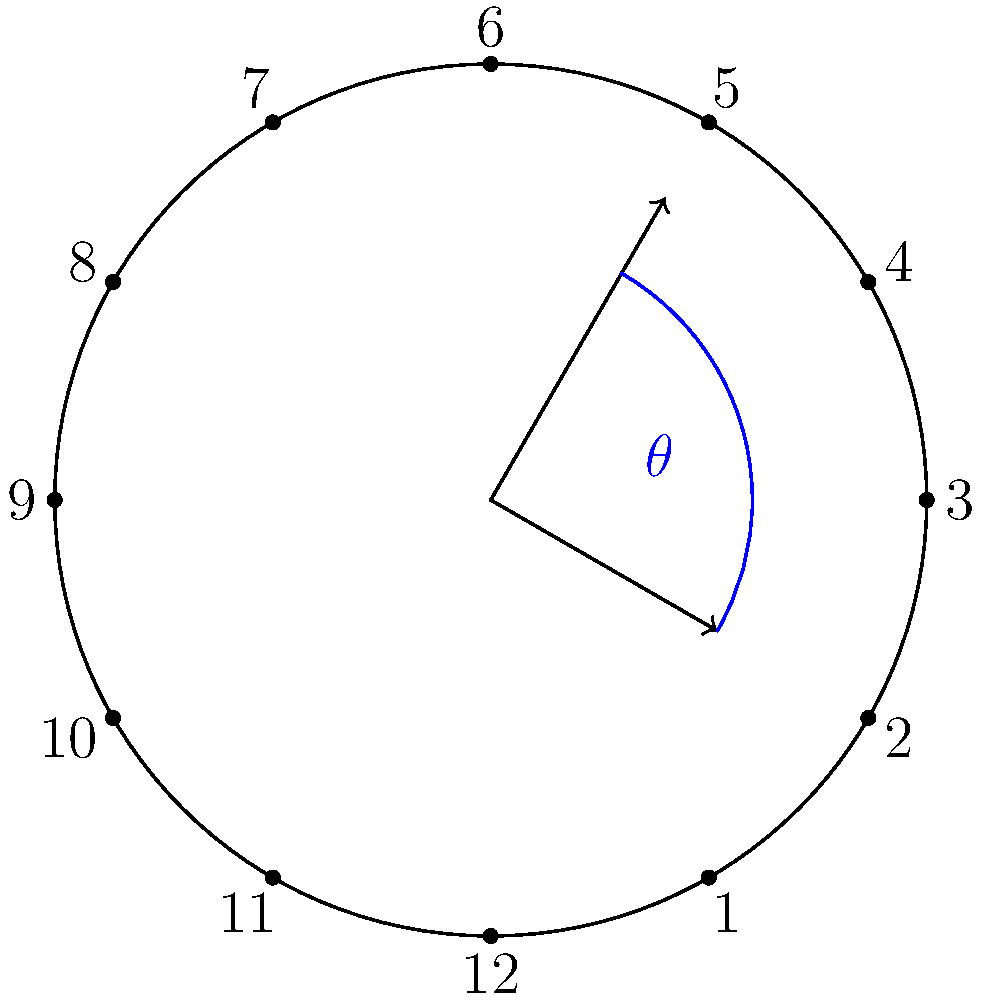Your child is learning to tell time on an analog clock. At 2:20, what is the angle between the hour hand and the minute hand? (Hint: Consider the movement of both hands.) Let's approach this step-by-step:

1. On a clock, there are 360° in a full rotation.

2. For the hour hand:
   - In 12 hours, it rotates 360°
   - In 1 hour, it rotates 360° ÷ 12 = 30°
   - In 20 minutes (1/3 of an hour), it rotates an additional 30° ÷ 3 = 10°
   - So at 2:20, the hour hand has rotated: (2 × 30°) + 10° = 70° from the 12 o'clock position

3. For the minute hand:
   - In 60 minutes, it rotates 360°
   - In 1 minute, it rotates 360° ÷ 60 = 6°
   - In 20 minutes, it rotates 20 × 6° = 120° from the 12 o'clock position

4. The angle between the hands is the absolute difference:
   $|\text{Minute hand position} - \text{Hour hand position}| = |120° - 70°| = 50°$

Therefore, the angle between the hour hand and the minute hand at 2:20 is 50°.
Answer: 50° 